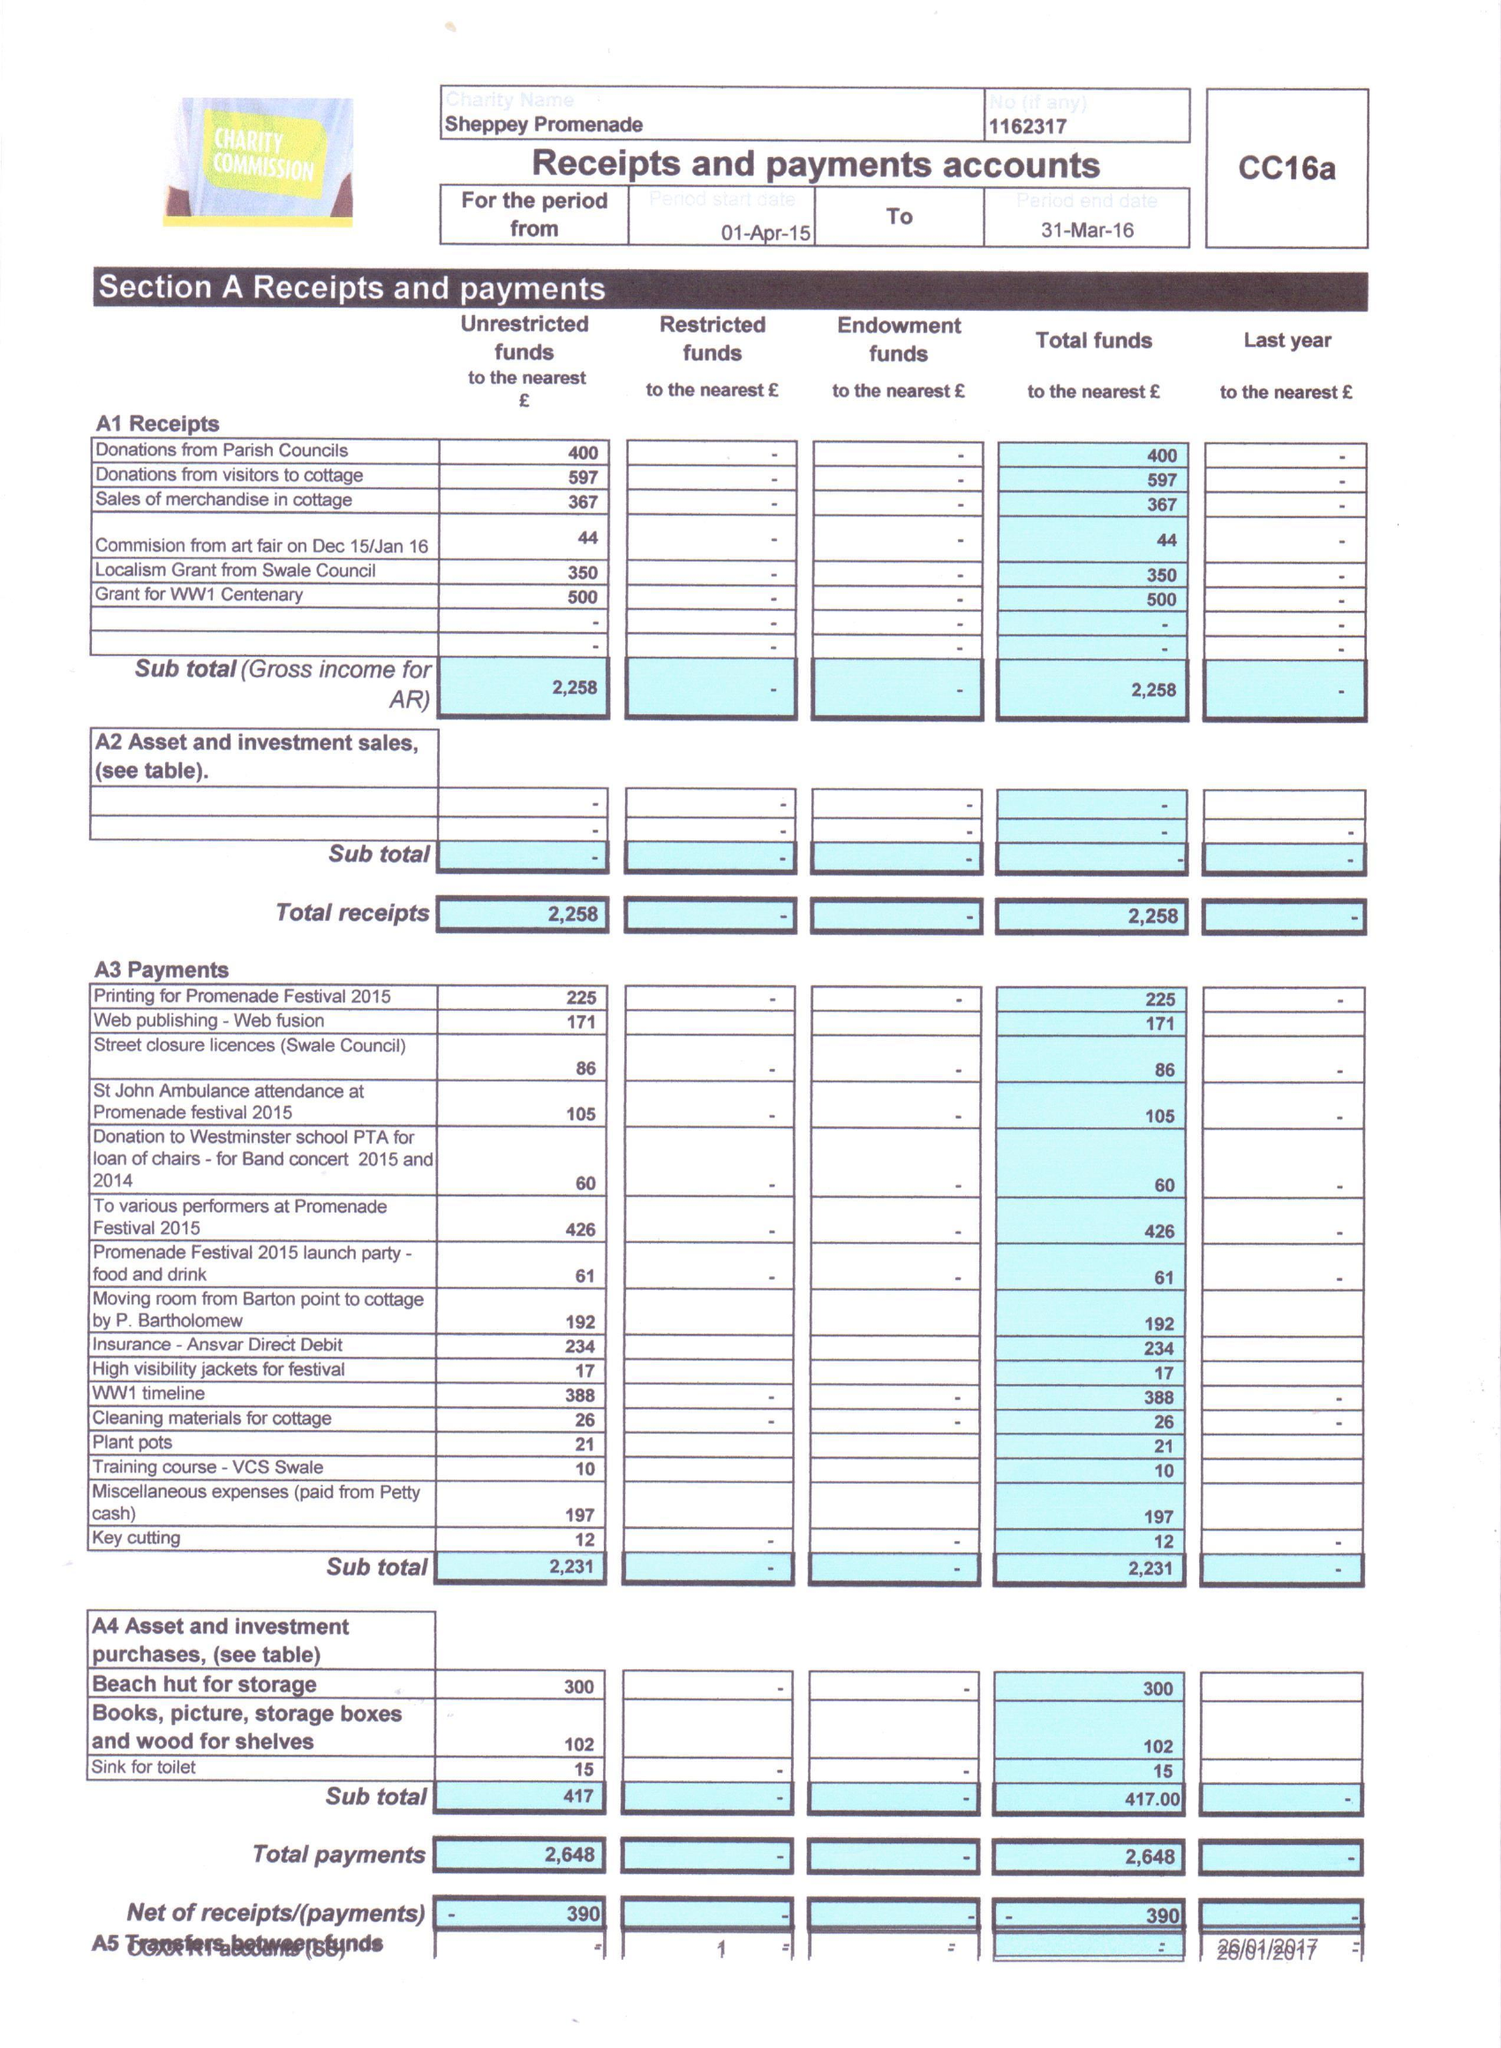What is the value for the charity_name?
Answer the question using a single word or phrase. Sheppey Promenade 